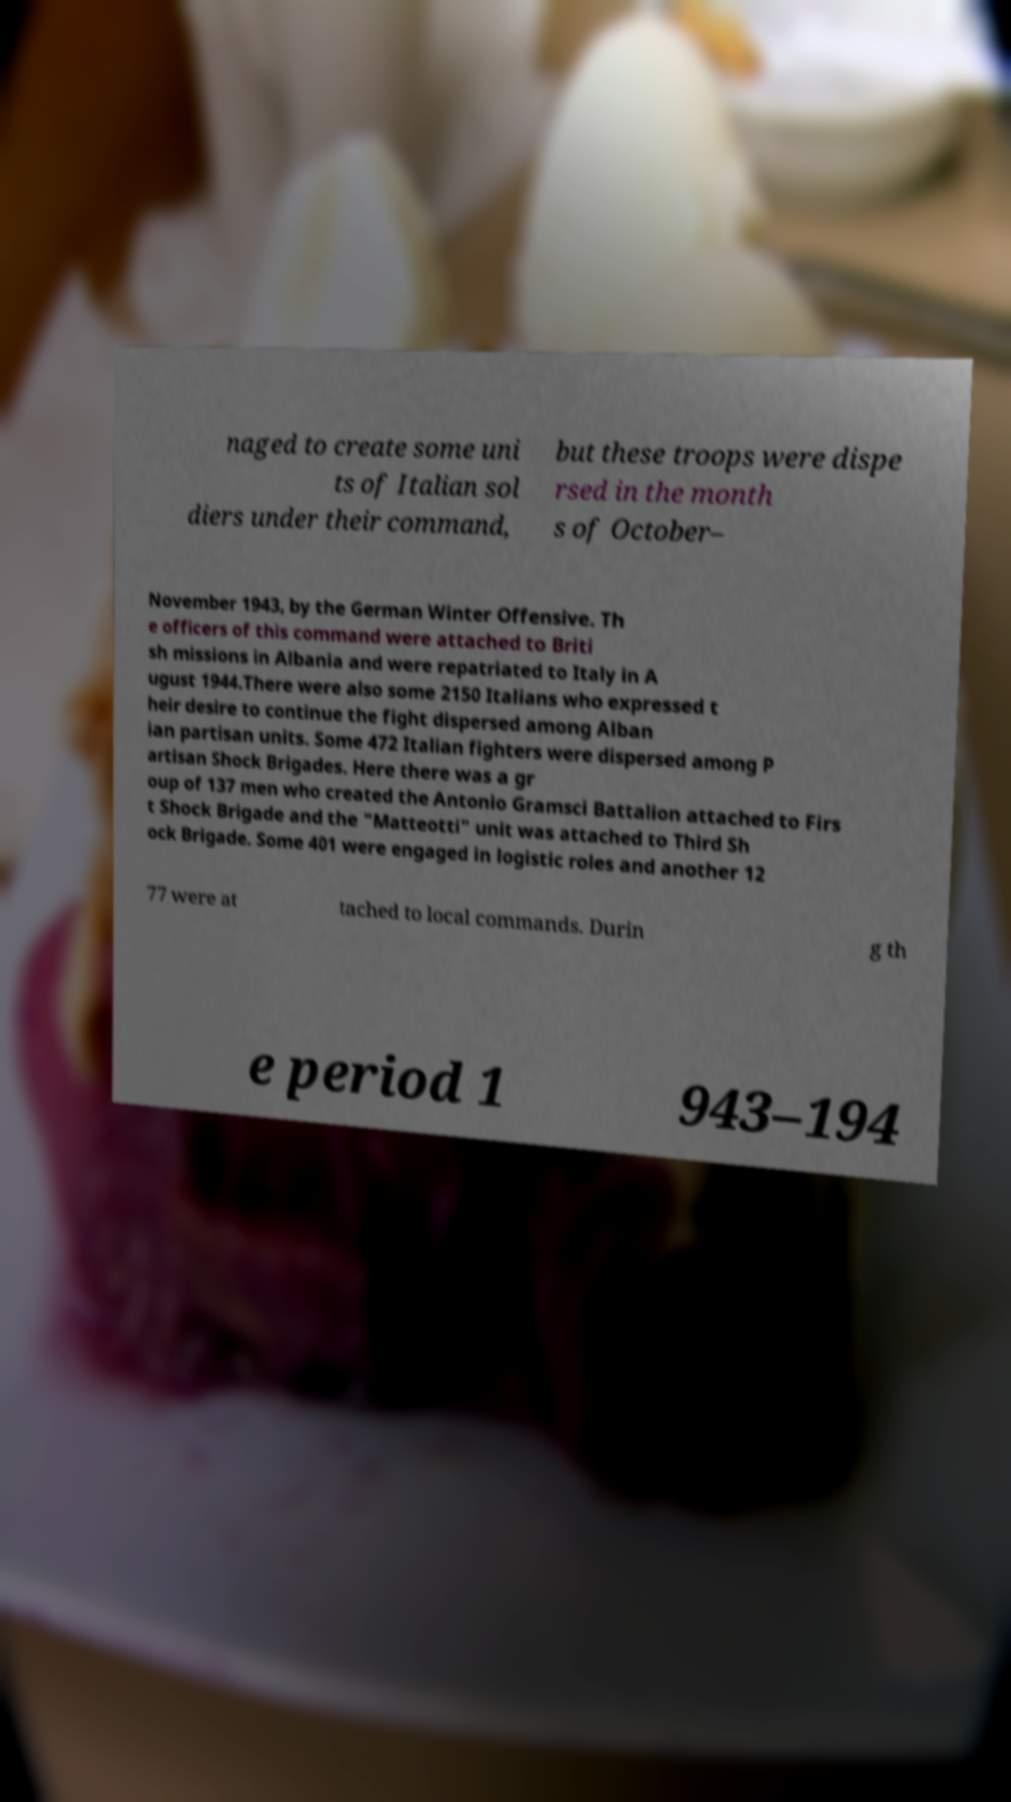Please read and relay the text visible in this image. What does it say? naged to create some uni ts of Italian sol diers under their command, but these troops were dispe rsed in the month s of October– November 1943, by the German Winter Offensive. Th e officers of this command were attached to Briti sh missions in Albania and were repatriated to Italy in A ugust 1944.There were also some 2150 Italians who expressed t heir desire to continue the fight dispersed among Alban ian partisan units. Some 472 Italian fighters were dispersed among P artisan Shock Brigades. Here there was a gr oup of 137 men who created the Antonio Gramsci Battalion attached to Firs t Shock Brigade and the "Matteotti" unit was attached to Third Sh ock Brigade. Some 401 were engaged in logistic roles and another 12 77 were at tached to local commands. Durin g th e period 1 943–194 